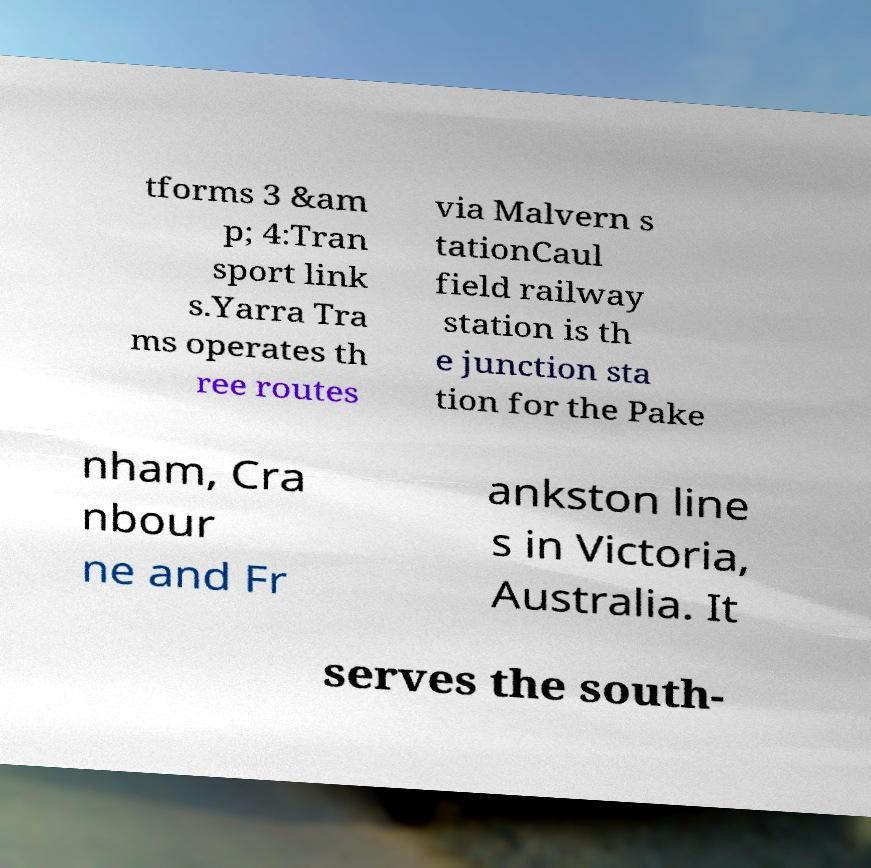There's text embedded in this image that I need extracted. Can you transcribe it verbatim? tforms 3 &am p; 4:Tran sport link s.Yarra Tra ms operates th ree routes via Malvern s tationCaul field railway station is th e junction sta tion for the Pake nham, Cra nbour ne and Fr ankston line s in Victoria, Australia. It serves the south- 